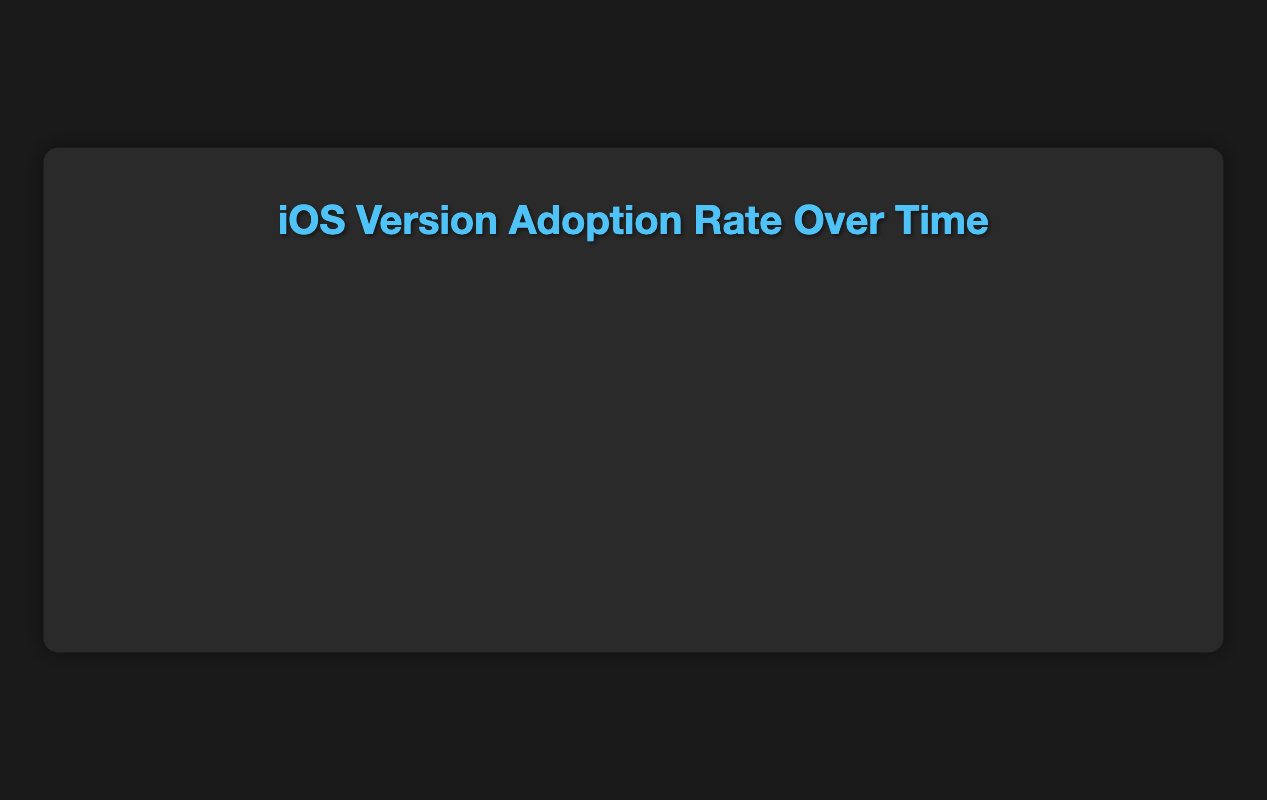What's the adoption rate of iOS 14 on 2021-07-01 and how does it compare to the adoption rate of iOS 16 on 2023-07-01? On 2021-07-01, iOS 14 had an adoption rate of 80.0%. On 2023-07-01, iOS 16 had an adoption rate of 65.0%. Comparing these values, iOS 14 had a higher adoption rate by 15%.
Answer: iOS 14 had a higher adoption rate by 15% Which iOS version had the highest adoption rate on 2022-04-01? On 2022-04-01, iOS 15 had the highest adoption rate at 55.0%. This can be observed by visually comparing the heights of the curves on the plot for that date.
Answer: iOS 15 What was the trend of iOS 13 adoption rate from 2021-01-01 to 2023-07-01? Starting from 2021-01-01, iOS 13 adoption rate decreased continuously from 15.0% until it reached 0.4% by 2023-07-01. This trend is visible by observing the downward slope of the iOS 13 curve over time.
Answer: Decreasing What is the combined adoption rate of iOS 14 and iOS 15 on 2022-01-01? On 2022-01-01, iOS 14 had an adoption rate of 50.0% and iOS 15 had 40.0%. Summing them up gives a combined rate of 90.0%.
Answer: 90.0% In which quarter did iOS 16 first appear, and what was its initial adoption rate? iOS 16 first appeared in the fourth quarter of 2022 (2022-10-01) with an initial adoption rate of 10.0%. This can be verified by finding the first instance where iOS 16 appears on the plot.
Answer: Q4 2022, 10.0% How did the adoption rate of iOS 15 change from 2022-10-01 to 2023-10-01? On 2022-10-01, iOS 15 had an adoption rate of 65.0%. By 2023-10-01, it had decreased to 12.0%. The change can be calculated by subtracting the latter from the former, which is a decrease of 53.0%.
Answer: Decreased by 53.0% Which iOS version saw the steepest decline in adoption rate between 2023-04-01 and 2023-07-01? Between 2023-04-01 (45.0%) and 2023-07-01 (30.0%), iOS 15 saw the steepest decline, which is 15.0%. This can be seen by comparing the vertical drops of different versions on the plot.
Answer: iOS 15 What is the average adoption rate of iOS 16 from its initial appearance to 2023-10-01? iOS 16 had the following adoption rates: 10.0%, 25.0%, 45.0%, 65.0%, 70.0%. Summing these gives (10.0 + 25.0 + 45.0 + 65.0 + 70.0) = 215.0%. The average rate is then 215.0 / 5 = 43.0%.
Answer: 43.0% What color represents iOS 17 in the chart, and what is its adoption rate on 2023-10-01? The color representing iOS 17 is red. On 2023-10-01, iOS 17 has an adoption rate of 15.0%, as shown in the legend and by the height of the corresponding part of the curve on that date.
Answer: Red, 15.0% 